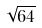<formula> <loc_0><loc_0><loc_500><loc_500>\sqrt { 6 4 }</formula> 